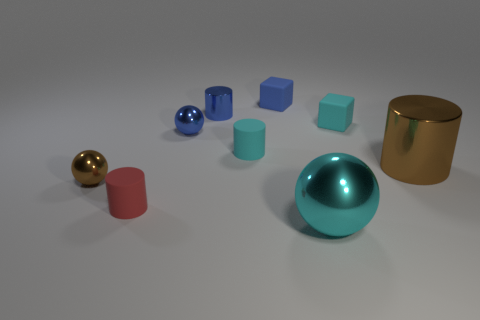How many small things are either gray cylinders or brown metallic cylinders?
Keep it short and to the point. 0. What is the size of the cyan ball on the left side of the small cyan thing behind the rubber cylinder behind the small brown sphere?
Keep it short and to the point. Large. The tiny block that is left of the small cyan matte object behind the small matte cylinder that is right of the small red thing is made of what material?
Provide a succinct answer. Rubber. Is the big brown metallic thing the same shape as the big cyan metal thing?
Your answer should be very brief. No. How many metallic things are both to the left of the big cyan shiny thing and right of the small brown ball?
Provide a succinct answer. 2. What is the color of the rubber block behind the tiny rubber block that is to the right of the large metal sphere?
Give a very brief answer. Blue. Is the number of large shiny things that are on the right side of the big metal cylinder the same as the number of yellow matte things?
Give a very brief answer. Yes. There is a small red rubber thing that is in front of the brown ball that is to the left of the blue block; what number of rubber cylinders are to the right of it?
Give a very brief answer. 1. What color is the small shiny thing that is in front of the big brown metallic cylinder?
Your response must be concise. Brown. What is the material of the thing that is on the right side of the large cyan shiny ball and to the left of the big metallic cylinder?
Keep it short and to the point. Rubber. 